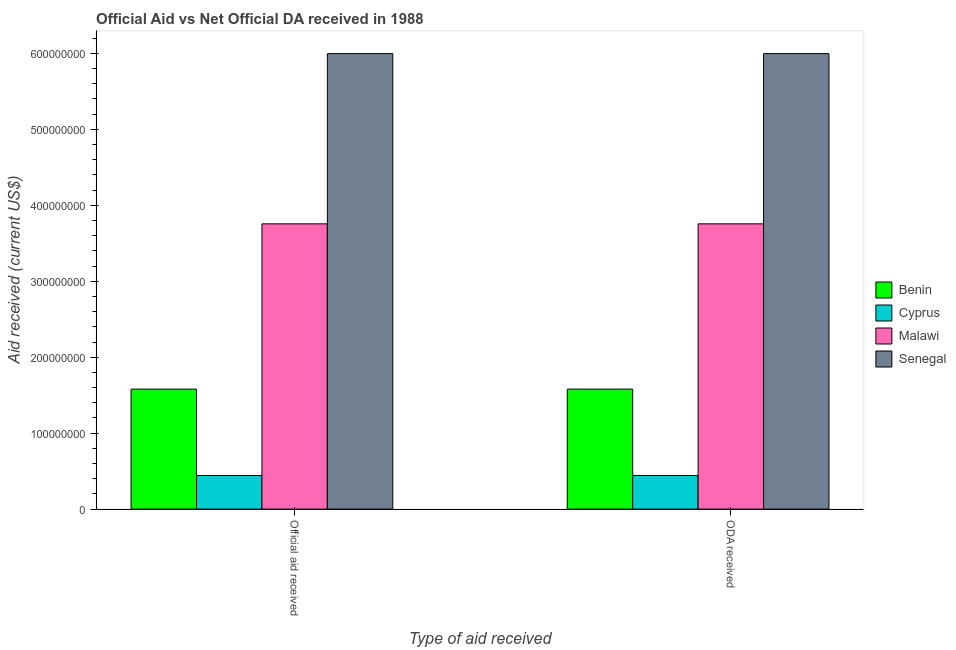Are the number of bars per tick equal to the number of legend labels?
Offer a very short reply. Yes. Are the number of bars on each tick of the X-axis equal?
Keep it short and to the point. Yes. How many bars are there on the 1st tick from the right?
Give a very brief answer. 4. What is the label of the 1st group of bars from the left?
Your answer should be compact. Official aid received. What is the oda received in Benin?
Make the answer very short. 1.58e+08. Across all countries, what is the maximum official aid received?
Provide a short and direct response. 6.00e+08. Across all countries, what is the minimum official aid received?
Make the answer very short. 4.42e+07. In which country was the official aid received maximum?
Give a very brief answer. Senegal. In which country was the official aid received minimum?
Keep it short and to the point. Cyprus. What is the total official aid received in the graph?
Make the answer very short. 1.18e+09. What is the difference between the official aid received in Senegal and that in Cyprus?
Make the answer very short. 5.56e+08. What is the difference between the oda received in Cyprus and the official aid received in Benin?
Your response must be concise. -1.14e+08. What is the average oda received per country?
Provide a succinct answer. 2.94e+08. In how many countries, is the oda received greater than 100000000 US$?
Your answer should be compact. 3. What is the ratio of the official aid received in Senegal to that in Benin?
Offer a very short reply. 3.8. Is the oda received in Senegal less than that in Cyprus?
Give a very brief answer. No. In how many countries, is the official aid received greater than the average official aid received taken over all countries?
Your answer should be compact. 2. What does the 3rd bar from the left in ODA received represents?
Ensure brevity in your answer.  Malawi. What does the 3rd bar from the right in Official aid received represents?
Provide a short and direct response. Cyprus. How many countries are there in the graph?
Provide a succinct answer. 4. Are the values on the major ticks of Y-axis written in scientific E-notation?
Your response must be concise. No. Does the graph contain grids?
Ensure brevity in your answer.  No. Where does the legend appear in the graph?
Your response must be concise. Center right. How many legend labels are there?
Offer a very short reply. 4. How are the legend labels stacked?
Keep it short and to the point. Vertical. What is the title of the graph?
Your response must be concise. Official Aid vs Net Official DA received in 1988 . Does "Greenland" appear as one of the legend labels in the graph?
Offer a very short reply. No. What is the label or title of the X-axis?
Keep it short and to the point. Type of aid received. What is the label or title of the Y-axis?
Your response must be concise. Aid received (current US$). What is the Aid received (current US$) of Benin in Official aid received?
Provide a succinct answer. 1.58e+08. What is the Aid received (current US$) in Cyprus in Official aid received?
Keep it short and to the point. 4.42e+07. What is the Aid received (current US$) in Malawi in Official aid received?
Provide a short and direct response. 3.76e+08. What is the Aid received (current US$) in Senegal in Official aid received?
Provide a succinct answer. 6.00e+08. What is the Aid received (current US$) of Benin in ODA received?
Provide a succinct answer. 1.58e+08. What is the Aid received (current US$) in Cyprus in ODA received?
Keep it short and to the point. 4.42e+07. What is the Aid received (current US$) in Malawi in ODA received?
Ensure brevity in your answer.  3.76e+08. What is the Aid received (current US$) in Senegal in ODA received?
Ensure brevity in your answer.  6.00e+08. Across all Type of aid received, what is the maximum Aid received (current US$) in Benin?
Your answer should be compact. 1.58e+08. Across all Type of aid received, what is the maximum Aid received (current US$) in Cyprus?
Keep it short and to the point. 4.42e+07. Across all Type of aid received, what is the maximum Aid received (current US$) in Malawi?
Make the answer very short. 3.76e+08. Across all Type of aid received, what is the maximum Aid received (current US$) in Senegal?
Ensure brevity in your answer.  6.00e+08. Across all Type of aid received, what is the minimum Aid received (current US$) of Benin?
Provide a succinct answer. 1.58e+08. Across all Type of aid received, what is the minimum Aid received (current US$) of Cyprus?
Your answer should be very brief. 4.42e+07. Across all Type of aid received, what is the minimum Aid received (current US$) in Malawi?
Offer a very short reply. 3.76e+08. Across all Type of aid received, what is the minimum Aid received (current US$) in Senegal?
Provide a succinct answer. 6.00e+08. What is the total Aid received (current US$) of Benin in the graph?
Provide a short and direct response. 3.16e+08. What is the total Aid received (current US$) of Cyprus in the graph?
Provide a short and direct response. 8.84e+07. What is the total Aid received (current US$) in Malawi in the graph?
Offer a very short reply. 7.51e+08. What is the total Aid received (current US$) of Senegal in the graph?
Make the answer very short. 1.20e+09. What is the difference between the Aid received (current US$) of Benin in Official aid received and that in ODA received?
Offer a very short reply. 0. What is the difference between the Aid received (current US$) in Cyprus in Official aid received and that in ODA received?
Your answer should be compact. 0. What is the difference between the Aid received (current US$) of Malawi in Official aid received and that in ODA received?
Your response must be concise. 0. What is the difference between the Aid received (current US$) in Senegal in Official aid received and that in ODA received?
Provide a succinct answer. 0. What is the difference between the Aid received (current US$) in Benin in Official aid received and the Aid received (current US$) in Cyprus in ODA received?
Offer a terse response. 1.14e+08. What is the difference between the Aid received (current US$) in Benin in Official aid received and the Aid received (current US$) in Malawi in ODA received?
Your answer should be compact. -2.18e+08. What is the difference between the Aid received (current US$) in Benin in Official aid received and the Aid received (current US$) in Senegal in ODA received?
Provide a succinct answer. -4.42e+08. What is the difference between the Aid received (current US$) in Cyprus in Official aid received and the Aid received (current US$) in Malawi in ODA received?
Your answer should be compact. -3.31e+08. What is the difference between the Aid received (current US$) in Cyprus in Official aid received and the Aid received (current US$) in Senegal in ODA received?
Offer a very short reply. -5.56e+08. What is the difference between the Aid received (current US$) in Malawi in Official aid received and the Aid received (current US$) in Senegal in ODA received?
Provide a succinct answer. -2.24e+08. What is the average Aid received (current US$) of Benin per Type of aid received?
Offer a terse response. 1.58e+08. What is the average Aid received (current US$) of Cyprus per Type of aid received?
Your answer should be compact. 4.42e+07. What is the average Aid received (current US$) of Malawi per Type of aid received?
Your response must be concise. 3.76e+08. What is the average Aid received (current US$) of Senegal per Type of aid received?
Ensure brevity in your answer.  6.00e+08. What is the difference between the Aid received (current US$) of Benin and Aid received (current US$) of Cyprus in Official aid received?
Offer a terse response. 1.14e+08. What is the difference between the Aid received (current US$) of Benin and Aid received (current US$) of Malawi in Official aid received?
Provide a short and direct response. -2.18e+08. What is the difference between the Aid received (current US$) of Benin and Aid received (current US$) of Senegal in Official aid received?
Offer a very short reply. -4.42e+08. What is the difference between the Aid received (current US$) in Cyprus and Aid received (current US$) in Malawi in Official aid received?
Make the answer very short. -3.31e+08. What is the difference between the Aid received (current US$) of Cyprus and Aid received (current US$) of Senegal in Official aid received?
Offer a terse response. -5.56e+08. What is the difference between the Aid received (current US$) in Malawi and Aid received (current US$) in Senegal in Official aid received?
Ensure brevity in your answer.  -2.24e+08. What is the difference between the Aid received (current US$) of Benin and Aid received (current US$) of Cyprus in ODA received?
Make the answer very short. 1.14e+08. What is the difference between the Aid received (current US$) in Benin and Aid received (current US$) in Malawi in ODA received?
Give a very brief answer. -2.18e+08. What is the difference between the Aid received (current US$) of Benin and Aid received (current US$) of Senegal in ODA received?
Provide a succinct answer. -4.42e+08. What is the difference between the Aid received (current US$) of Cyprus and Aid received (current US$) of Malawi in ODA received?
Keep it short and to the point. -3.31e+08. What is the difference between the Aid received (current US$) of Cyprus and Aid received (current US$) of Senegal in ODA received?
Your answer should be very brief. -5.56e+08. What is the difference between the Aid received (current US$) of Malawi and Aid received (current US$) of Senegal in ODA received?
Provide a short and direct response. -2.24e+08. What is the ratio of the Aid received (current US$) of Benin in Official aid received to that in ODA received?
Your answer should be very brief. 1. What is the ratio of the Aid received (current US$) in Cyprus in Official aid received to that in ODA received?
Keep it short and to the point. 1. What is the ratio of the Aid received (current US$) of Malawi in Official aid received to that in ODA received?
Give a very brief answer. 1. What is the difference between the highest and the second highest Aid received (current US$) in Benin?
Provide a succinct answer. 0. What is the difference between the highest and the lowest Aid received (current US$) of Senegal?
Give a very brief answer. 0. 